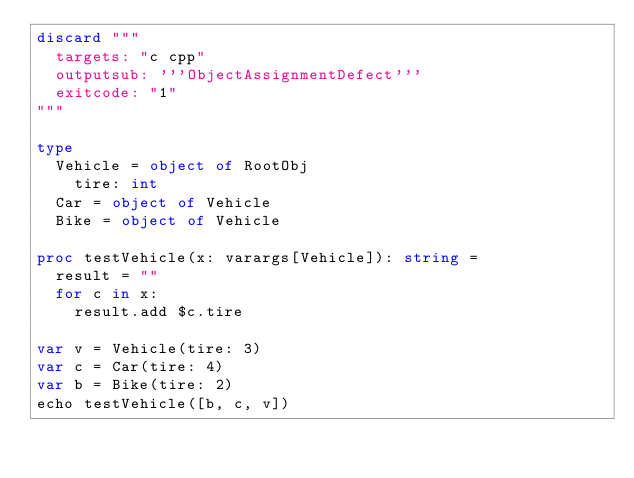Convert code to text. <code><loc_0><loc_0><loc_500><loc_500><_Nim_>discard """
  targets: "c cpp"
  outputsub: '''ObjectAssignmentDefect'''
  exitcode: "1"
"""

type
  Vehicle = object of RootObj
    tire: int
  Car = object of Vehicle
  Bike = object of Vehicle

proc testVehicle(x: varargs[Vehicle]): string =
  result = ""
  for c in x:
    result.add $c.tire

var v = Vehicle(tire: 3)
var c = Car(tire: 4)
var b = Bike(tire: 2)
echo testVehicle([b, c, v])</code> 